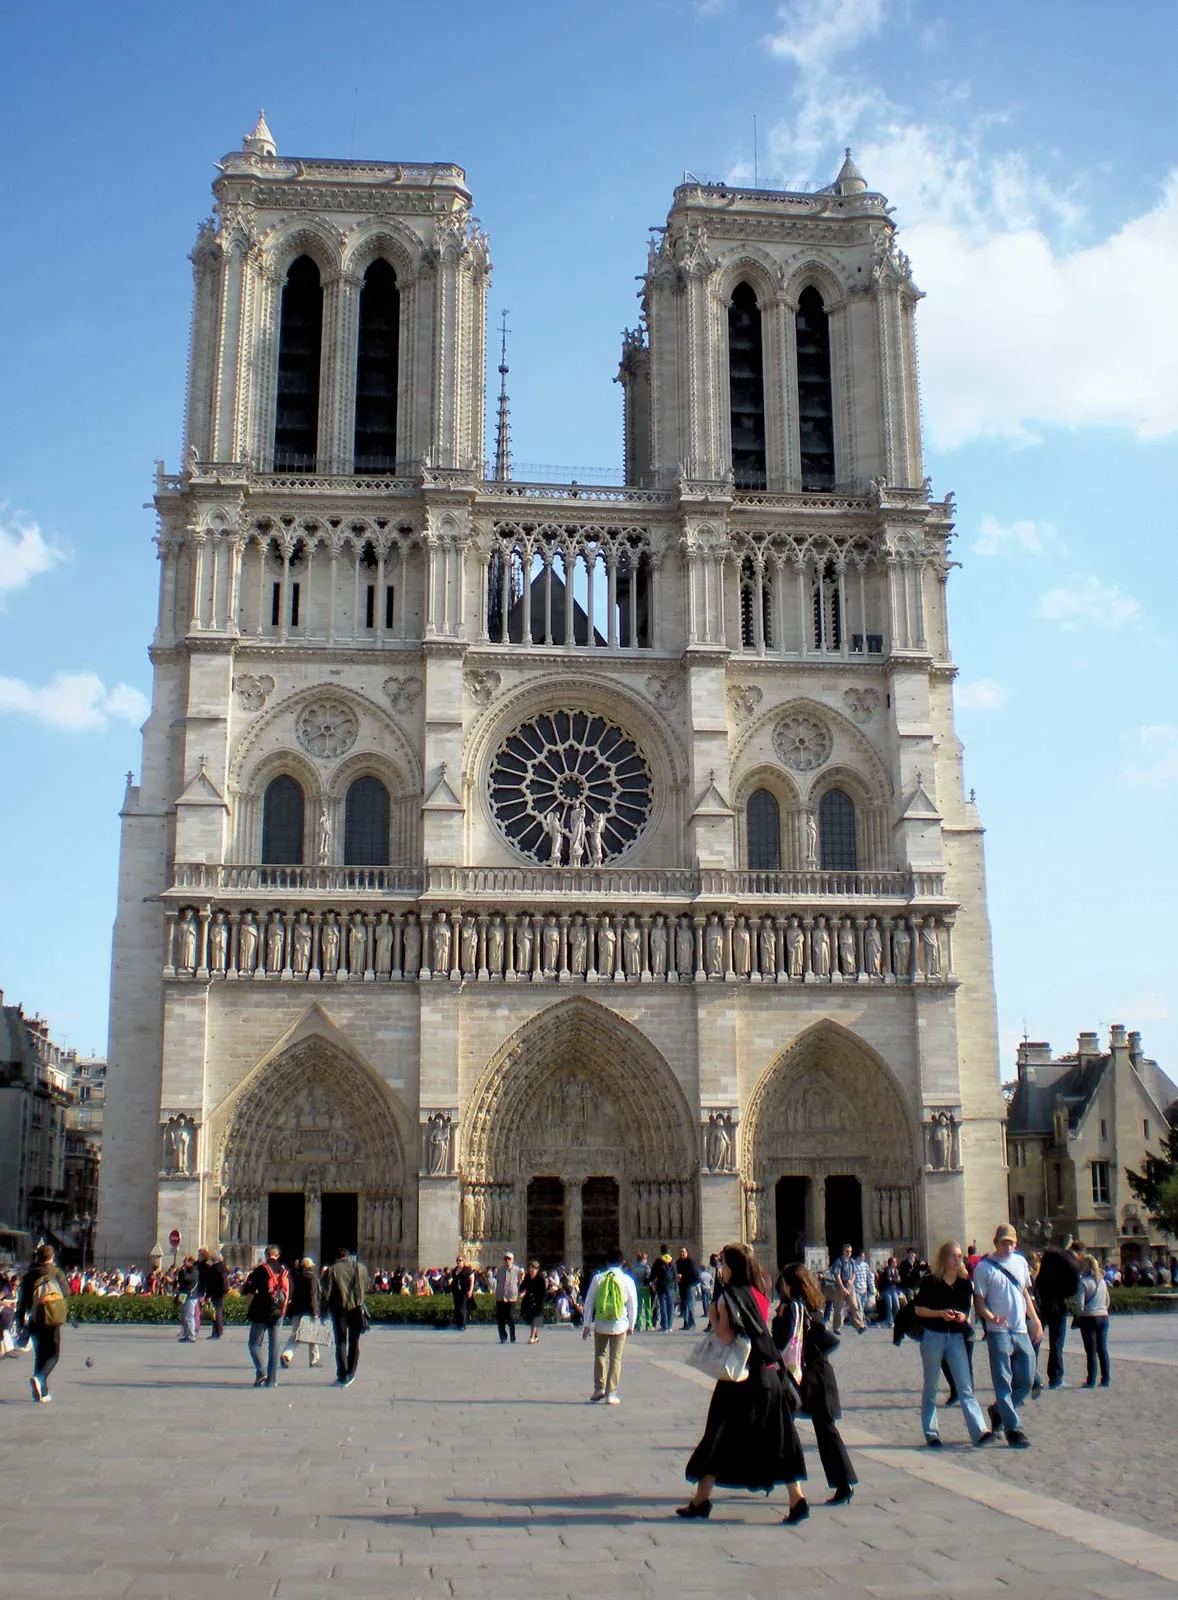Imagine if this cathedral could tell stories. What would it say about the people who have visited it over the centuries? If the Notre Dame Cathedral could speak, it would share countless tales of the diverse array of individuals who have passed through its grand portals. It would recount the medieval pilgrims who journeyed for days to pray at its altars, seeking solace and divine intervention. The cathedral would speak of the regal splendor of coronations and royal weddings, echoing the grandeur of kings and queens who once walked its aisles. It would recollect the revolutionaries who, during times of upheaval, stormed its sacred halls, leaving their fervent mark on history. In more recent times, it would tell of the everyday tourists, captivated by its beauty, snapping photos and silently marveling at its timeless grandeur. Each visitor, whether a historical figure or an anonymous admirer, has left an indelible mark on the cathedral’s enduring legacy. 